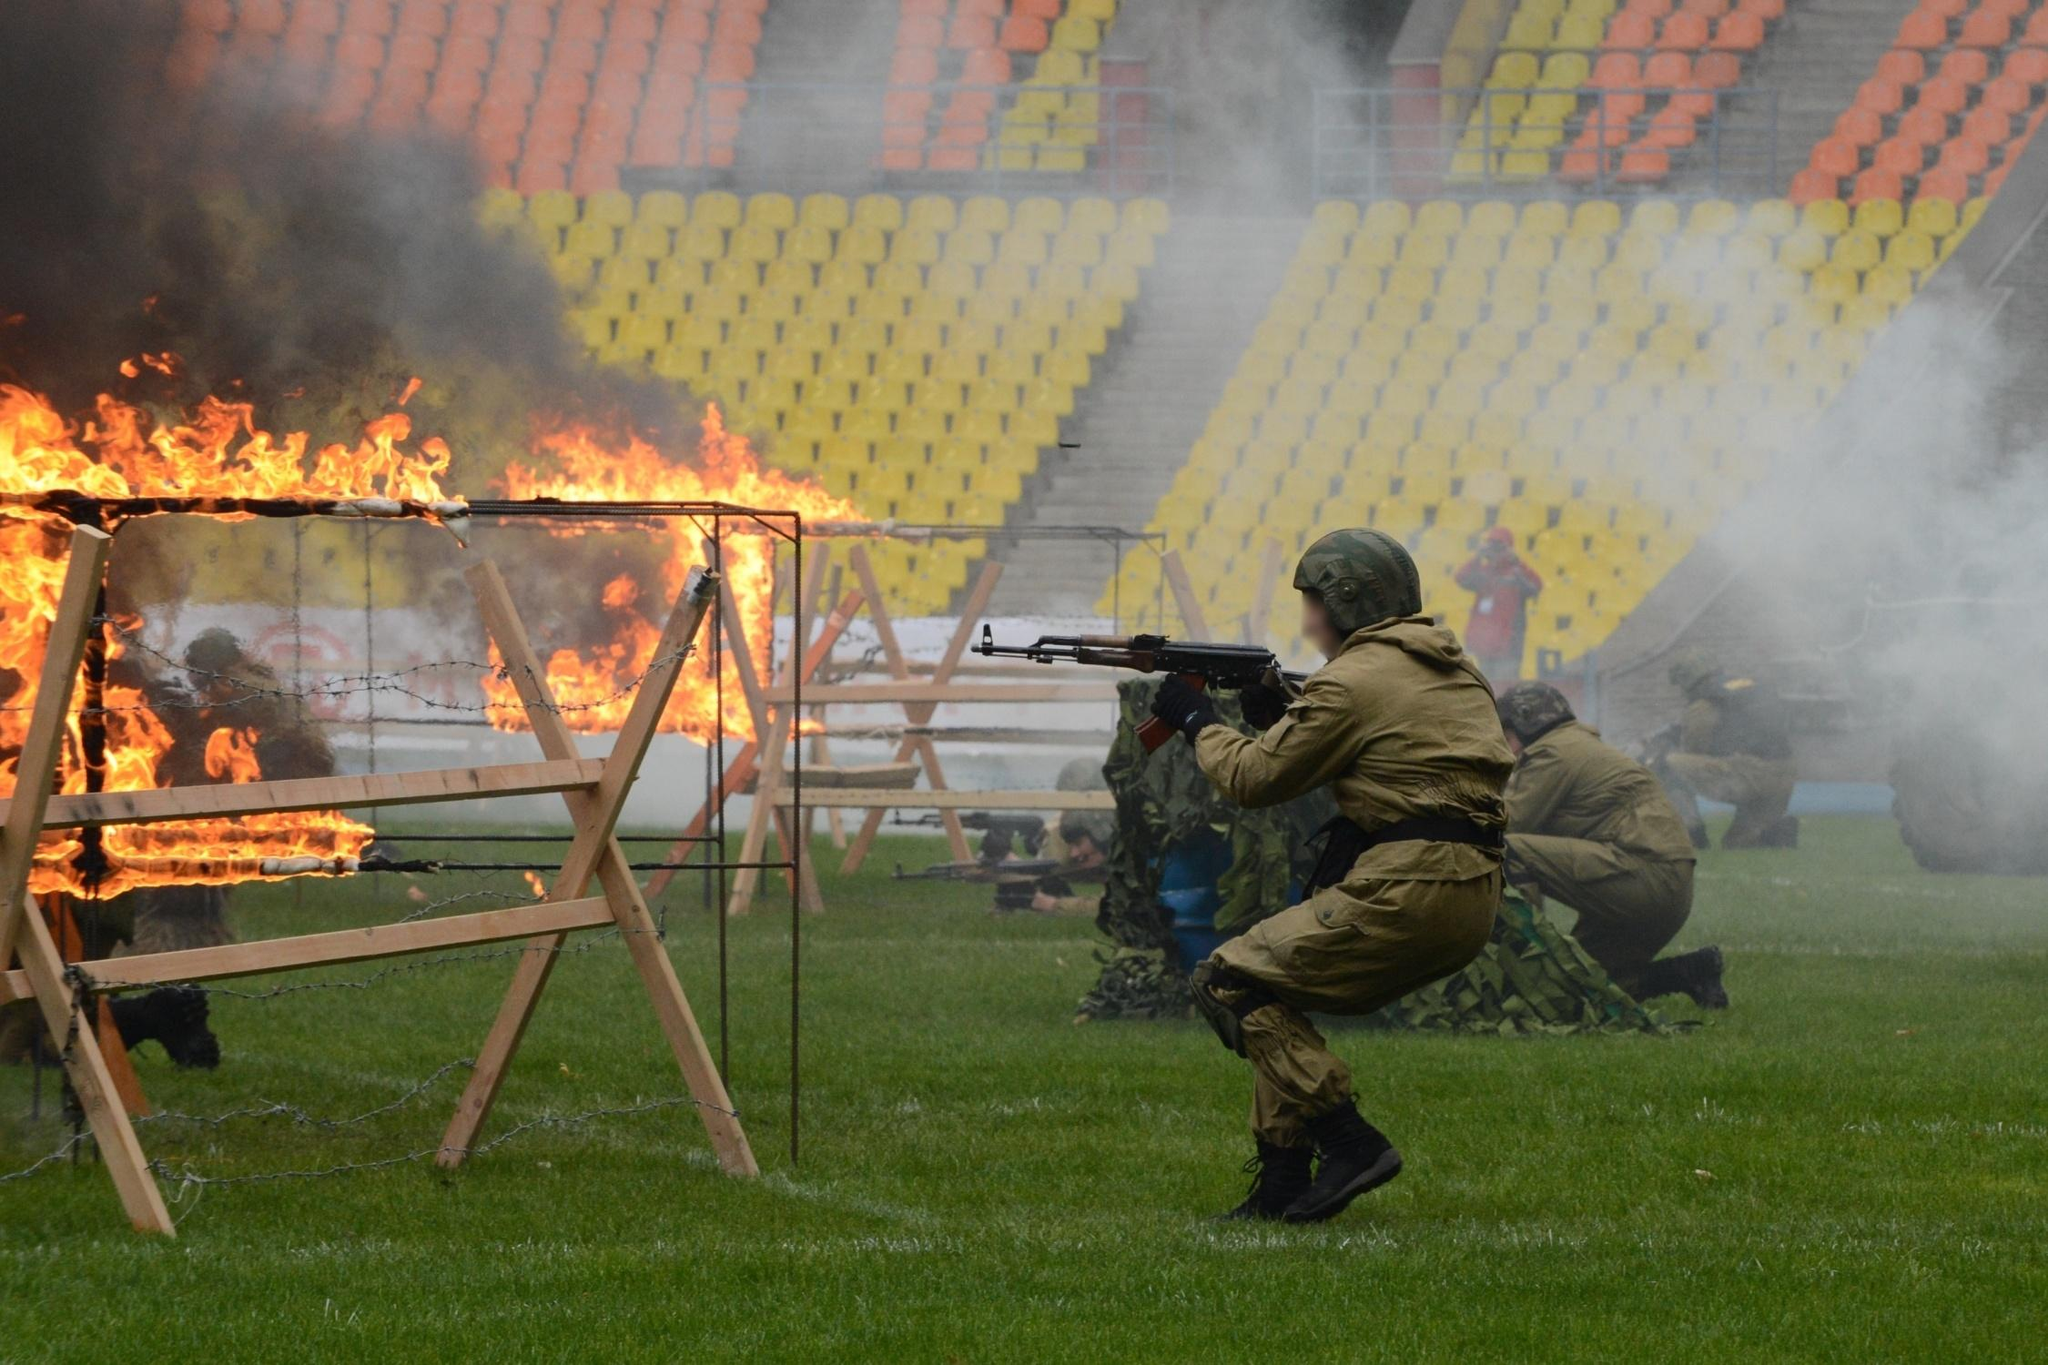How does the setting of a football stadium affect the perception of this military exercise? Using a football stadium as the setting for a military exercise juxtaposes typical recreational use with serious, tactical training, which may heighten the impact and public awareness about the military’s readiness and the nature of their operations. It underscores a dual use of public spaces and might suggest a metaphor about defense strategies playing out in everyday venues. Is there significance to the use of fire in this training scenario? Yes, incorporating fire into the training exercise adds a level of realism and urgency, testing soldiers’ ability to maintain focus, make strategic decisions, and operate effectively under extreme conditions. It simulates potential battlefield elements they might face, enhancing their preparedness for real combat situations where such chaotic and hazardous conditions are present. 